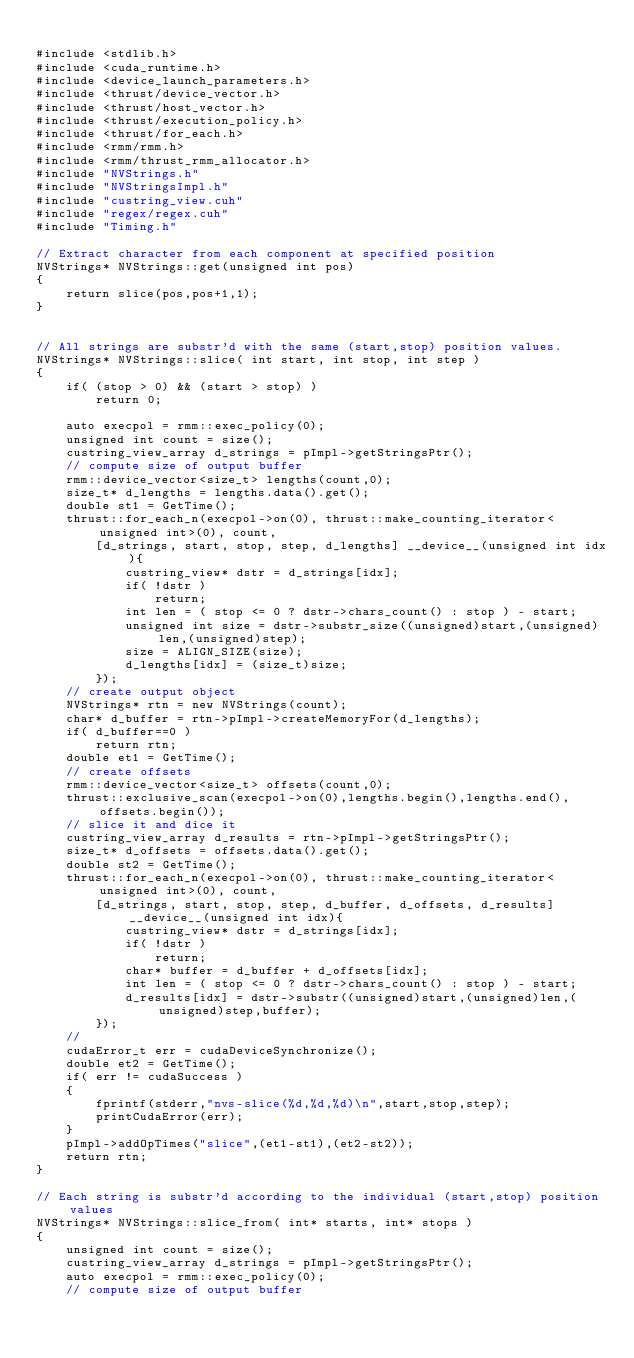Convert code to text. <code><loc_0><loc_0><loc_500><loc_500><_Cuda_>
#include <stdlib.h>
#include <cuda_runtime.h>
#include <device_launch_parameters.h>
#include <thrust/device_vector.h>
#include <thrust/host_vector.h>
#include <thrust/execution_policy.h>
#include <thrust/for_each.h>
#include <rmm/rmm.h>
#include <rmm/thrust_rmm_allocator.h>
#include "NVStrings.h"
#include "NVStringsImpl.h"
#include "custring_view.cuh"
#include "regex/regex.cuh"
#include "Timing.h"

// Extract character from each component at specified position
NVStrings* NVStrings::get(unsigned int pos)
{
    return slice(pos,pos+1,1);
}


// All strings are substr'd with the same (start,stop) position values.
NVStrings* NVStrings::slice( int start, int stop, int step )
{
    if( (stop > 0) && (start > stop) )
        return 0;

    auto execpol = rmm::exec_policy(0);
    unsigned int count = size();
    custring_view_array d_strings = pImpl->getStringsPtr();
    // compute size of output buffer
    rmm::device_vector<size_t> lengths(count,0);
    size_t* d_lengths = lengths.data().get();
    double st1 = GetTime();
    thrust::for_each_n(execpol->on(0), thrust::make_counting_iterator<unsigned int>(0), count,
        [d_strings, start, stop, step, d_lengths] __device__(unsigned int idx){
            custring_view* dstr = d_strings[idx];
            if( !dstr )
                return;
            int len = ( stop <= 0 ? dstr->chars_count() : stop ) - start;
            unsigned int size = dstr->substr_size((unsigned)start,(unsigned)len,(unsigned)step);
            size = ALIGN_SIZE(size);
            d_lengths[idx] = (size_t)size;
        });
    // create output object
    NVStrings* rtn = new NVStrings(count);
    char* d_buffer = rtn->pImpl->createMemoryFor(d_lengths);
    if( d_buffer==0 )
        return rtn;
    double et1 = GetTime();
    // create offsets
    rmm::device_vector<size_t> offsets(count,0);
    thrust::exclusive_scan(execpol->on(0),lengths.begin(),lengths.end(),offsets.begin());
    // slice it and dice it
    custring_view_array d_results = rtn->pImpl->getStringsPtr();
    size_t* d_offsets = offsets.data().get();
    double st2 = GetTime();
    thrust::for_each_n(execpol->on(0), thrust::make_counting_iterator<unsigned int>(0), count,
        [d_strings, start, stop, step, d_buffer, d_offsets, d_results] __device__(unsigned int idx){
            custring_view* dstr = d_strings[idx];
            if( !dstr )
                return;
            char* buffer = d_buffer + d_offsets[idx];
            int len = ( stop <= 0 ? dstr->chars_count() : stop ) - start;
            d_results[idx] = dstr->substr((unsigned)start,(unsigned)len,(unsigned)step,buffer);
        });
    //
    cudaError_t err = cudaDeviceSynchronize();
    double et2 = GetTime();
    if( err != cudaSuccess )
    {
        fprintf(stderr,"nvs-slice(%d,%d,%d)\n",start,stop,step);
        printCudaError(err);
    }
    pImpl->addOpTimes("slice",(et1-st1),(et2-st2));
    return rtn;
}

// Each string is substr'd according to the individual (start,stop) position values
NVStrings* NVStrings::slice_from( int* starts, int* stops )
{
    unsigned int count = size();
    custring_view_array d_strings = pImpl->getStringsPtr();
    auto execpol = rmm::exec_policy(0);
    // compute size of output buffer</code> 